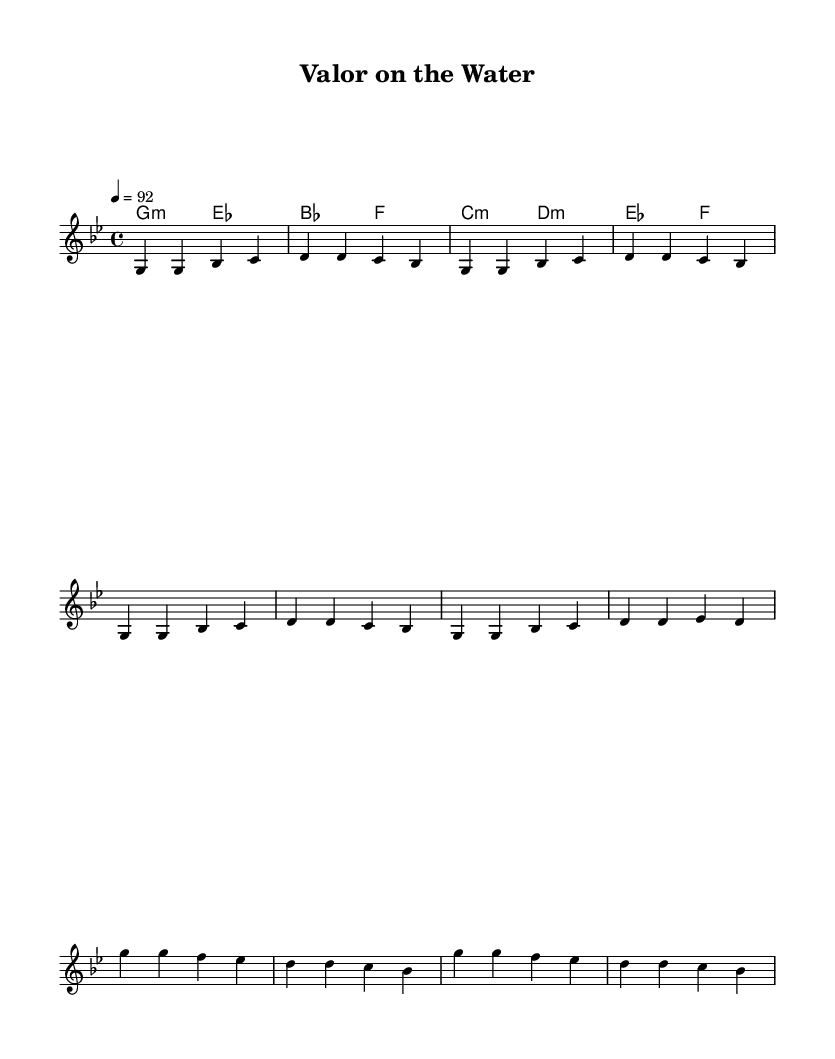What is the key signature of this music? The key signature is G minor, which has two flats (B♭ and E♭) in its key signature. This can be identified from the key signature notation in the beginning of the score.
Answer: G minor What is the time signature of this music? The time signature is 4/4, which indicates four beats in a measure and the quarter note gets one beat. This can be seen in the beginning of the score as well.
Answer: 4/4 What is the tempo marking of this piece? The tempo marking is 92 beats per minute, which means the music should be played at a moderate tempo. This is indicated in the tempo section of the score.
Answer: 92 How many measures are in the verse section? The verse section consists of 4 measures, which can be counted by identifying the groupings of bars in the melody part of the score.
Answer: 4 Which chord is played in the first measure? The chord played in the first measure is G minor. This can be determined by looking at the harmonic section of the score where the chords are indicated alongside the melody.
Answer: G minor Which musical style is reflected in this piece? The piece reflects the Hip Hop style, as indicated by its rhythmic structure and lyrical focus. This style is typical to celebrate themes like military service and sacrifice.
Answer: Hip Hop 